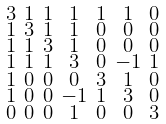<formula> <loc_0><loc_0><loc_500><loc_500>\begin{smallmatrix} 3 & 1 & 1 & 1 & 1 & 1 & 0 \\ 1 & 3 & 1 & 1 & 0 & 0 & 0 \\ 1 & 1 & 3 & 1 & 0 & 0 & 0 \\ 1 & 1 & 1 & 3 & 0 & - 1 & 1 \\ 1 & 0 & 0 & 0 & 3 & 1 & 0 \\ 1 & 0 & 0 & - 1 & 1 & 3 & 0 \\ 0 & 0 & 0 & 1 & 0 & 0 & 3 \end{smallmatrix}</formula> 